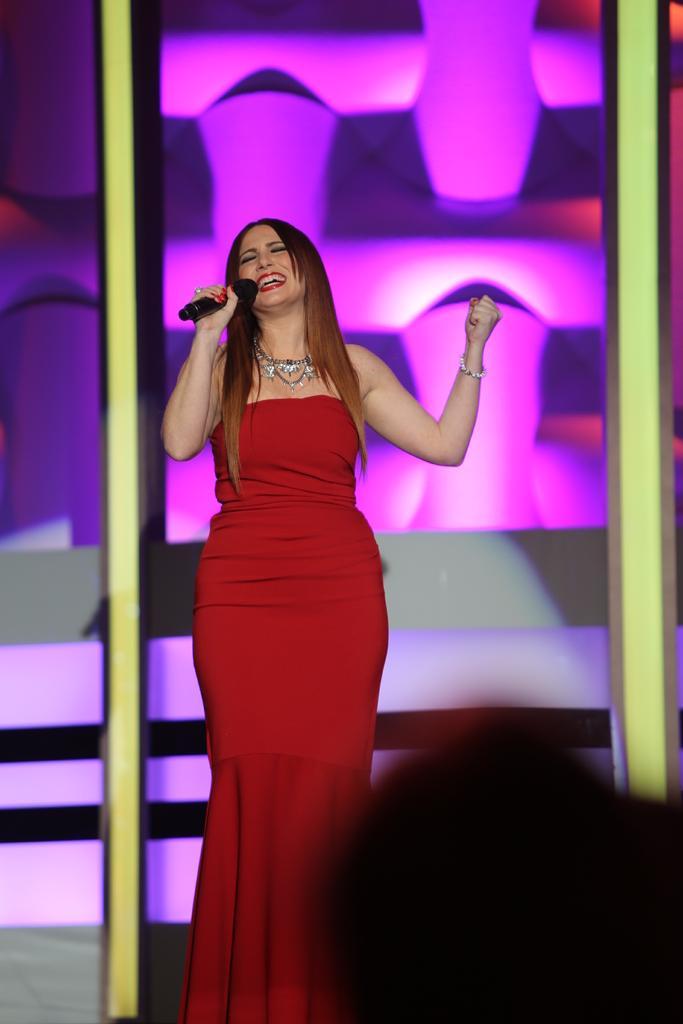How would you summarize this image in a sentence or two? In this image, in the middle, we can see a woman wearing a red color dress and holding a microphone in his hand. In the left corner, we can see an object. In the background, we can see a door with some pictures. 